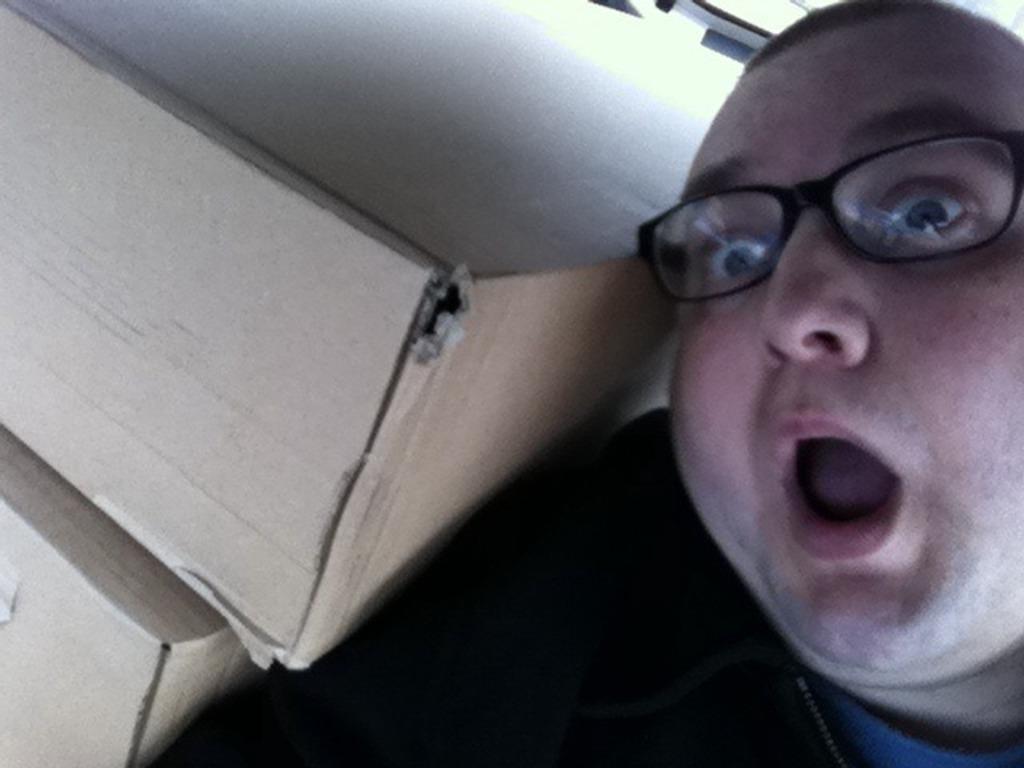Could you give a brief overview of what you see in this image? In the image we can see there is a man and he is wearing spectacles. Beside him there are two cardboard boxes. 